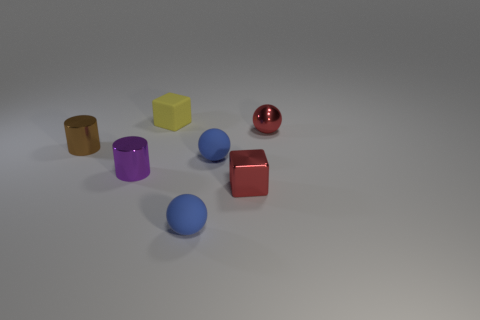Add 1 small red blocks. How many objects exist? 8 Subtract all balls. How many objects are left? 4 Subtract 1 red blocks. How many objects are left? 6 Subtract all purple things. Subtract all red shiny cubes. How many objects are left? 5 Add 5 small red cubes. How many small red cubes are left? 6 Add 7 tiny matte blocks. How many tiny matte blocks exist? 8 